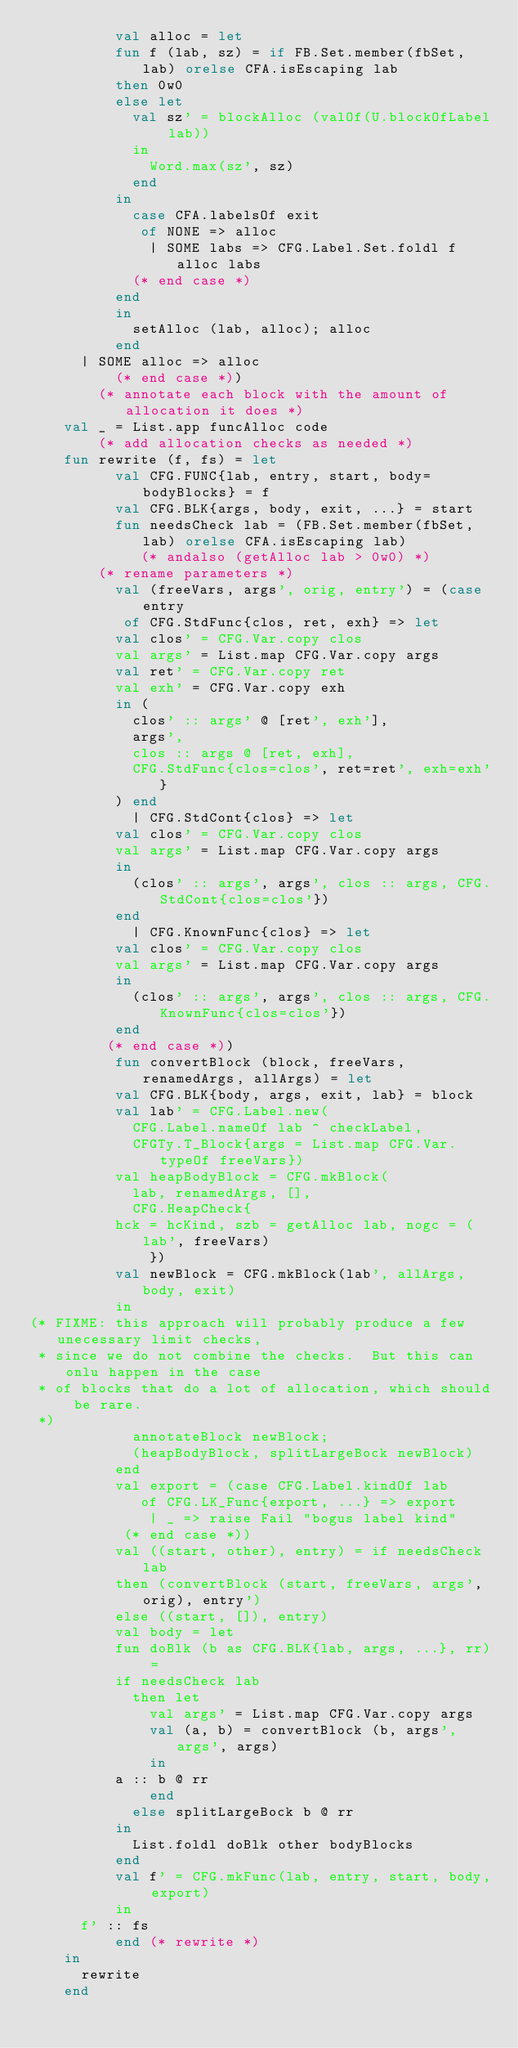Convert code to text. <code><loc_0><loc_0><loc_500><loc_500><_SML_>			    val alloc = let
				  fun f (lab, sz) = if FB.Set.member(fbSet, lab) orelse CFA.isEscaping lab
					then 0w0
					else let
					  val sz' = blockAlloc (valOf(U.blockOfLabel lab))
					  in
					    Word.max(sz', sz)
					  end
				  in
				    case CFA.labelsOf exit
				     of NONE => alloc
				      | SOME labs => CFG.Label.Set.foldl f alloc labs
				    (* end case *)
				  end
			    in
			      setAlloc (lab, alloc); alloc
			    end
			| SOME alloc => alloc
		      (* end case *))
	      (* annotate each block with the amount of allocation it does *)
		val _ = List.app funcAlloc code
	      (* add allocation checks as needed *)
		fun rewrite (f, fs) = let
		      val CFG.FUNC{lab, entry, start, body=bodyBlocks} = f
		      val CFG.BLK{args, body, exit, ...} = start
		      fun needsCheck lab = (FB.Set.member(fbSet, lab) orelse CFA.isEscaping lab)
					   (* andalso (getAlloc lab > 0w0) *)
		    (* rename parameters *)
		      val (freeVars, args', orig, entry') = (case entry
			     of CFG.StdFunc{clos, ret, exh} => let
				  val clos' = CFG.Var.copy clos
				  val args' = List.map CFG.Var.copy args
				  val ret' = CFG.Var.copy ret
				  val exh' = CFG.Var.copy exh
				  in (
				    clos' :: args' @ [ret', exh'],
				    args',
				    clos :: args @ [ret, exh],
				    CFG.StdFunc{clos=clos', ret=ret', exh=exh'}
				  ) end
			      | CFG.StdCont{clos} => let
				  val clos' = CFG.Var.copy clos
				  val args' = List.map CFG.Var.copy args
				  in
				    (clos' :: args', args', clos :: args, CFG.StdCont{clos=clos'})
				  end
			      | CFG.KnownFunc{clos} => let
				  val clos' = CFG.Var.copy clos
				  val args' = List.map CFG.Var.copy args
				  in
				    (clos' :: args', args', clos :: args, CFG.KnownFunc{clos=clos'})
				  end
			   (* end case *))
		      fun convertBlock (block, freeVars, renamedArgs, allArgs) = let
			    val CFG.BLK{body, args, exit, lab} = block
			    val lab' = CFG.Label.new(
				    CFG.Label.nameOf lab ^ checkLabel,
				    CFGTy.T_Block{args = List.map CFG.Var.typeOf freeVars})
			    val heapBodyBlock = CFG.mkBlock(
				    lab, renamedArgs, [],
				    CFG.HeapCheck{
					hck = hcKind, szb = getAlloc lab, nogc = (lab', freeVars)
				      })
			    val newBlock = CFG.mkBlock(lab', allArgs, body, exit)
			    in
(* FIXME: this approach will probably produce a few unecessary limit checks,
 * since we do not combine the checks.  But this can onlu happen in the case
 * of blocks that do a lot of allocation, which should be rare.
 *)
			      annotateBlock newBlock;
			      (heapBodyBlock, splitLargeBock newBlock)
			    end
		      val export = (case CFG.Label.kindOf lab
				     of CFG.LK_Func{export, ...} => export
				      | _ => raise Fail "bogus label kind"
				   (* end case *))
		      val ((start, other), entry) = if needsCheck lab
			    then (convertBlock (start, freeVars, args', orig), entry')
			    else ((start, []), entry)
		      val body = let
			    fun doBlk (b as CFG.BLK{lab, args, ...}, rr) =
				  if needsCheck lab
				    then let
				      val args' = List.map CFG.Var.copy args
				      val (a, b) = convertBlock (b, args', args', args)
				      in
					a :: b @ rr
				      end
				    else splitLargeBock b @ rr
			    in
			      List.foldl doBlk other bodyBlocks
			    end
		      val f' = CFG.mkFunc(lab, entry, start, body, export)
		      in
			f' :: fs
		      end (* rewrite *)
		in
		  rewrite
		end</code> 